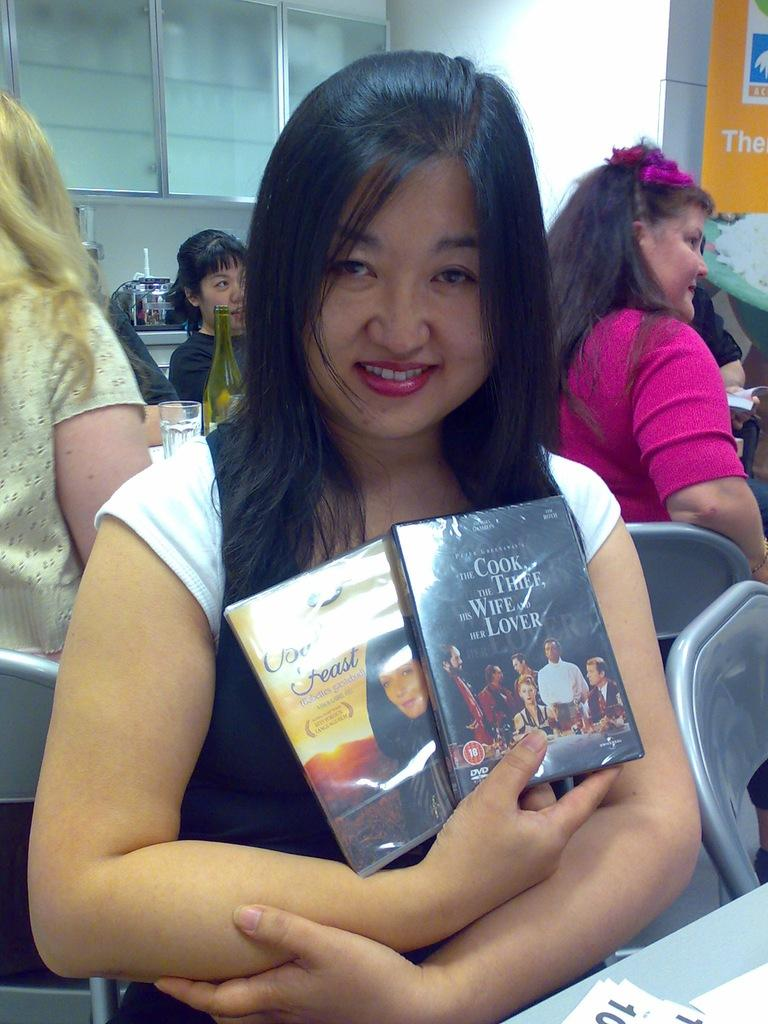Provide a one-sentence caption for the provided image. A woman holding two DVDs, one is The Cook the Thief his Wife and her Lover. 